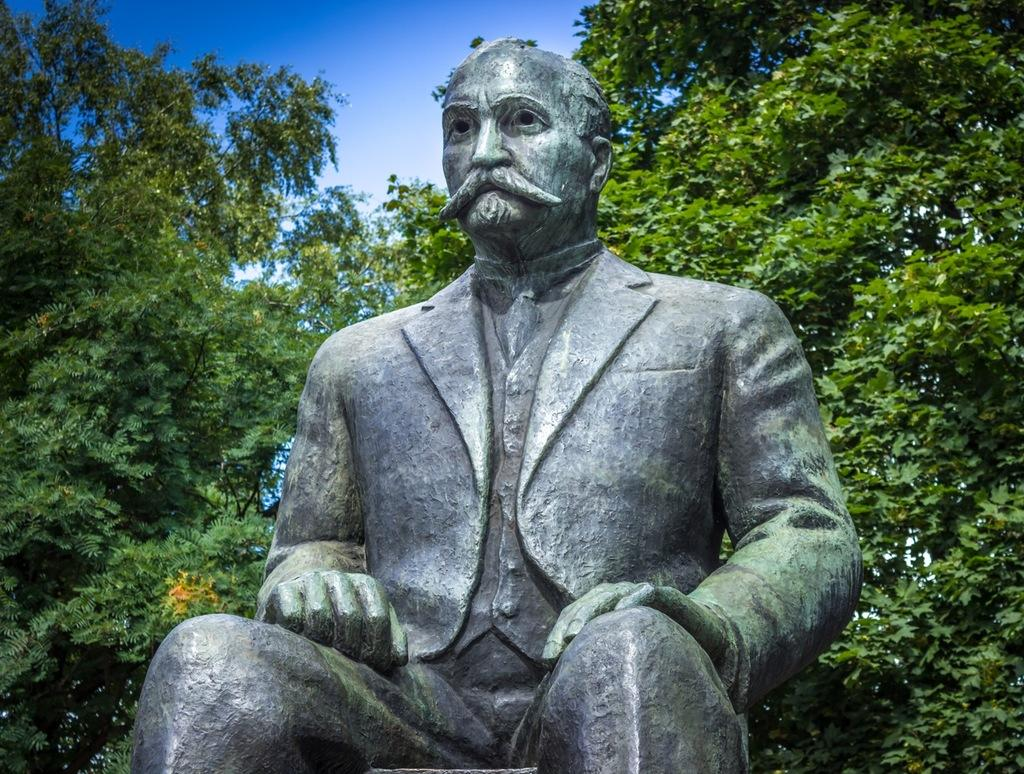What is the main subject of the image? The main subject of the image is a statue of a man. How is the man depicted in the statue? The statue depicts the man sitting. What can be seen in the background of the image? There are trees in the background of the image. What is visible at the top of the image? The sky is visible at the top of the image. How many dimes are placed on the statue's lap in the image? There are no dimes present on the statue's lap in the image. What type of bread is being offered to the statue in the image? There is no bread present in the image, and the statue is not interacting with any objects. 